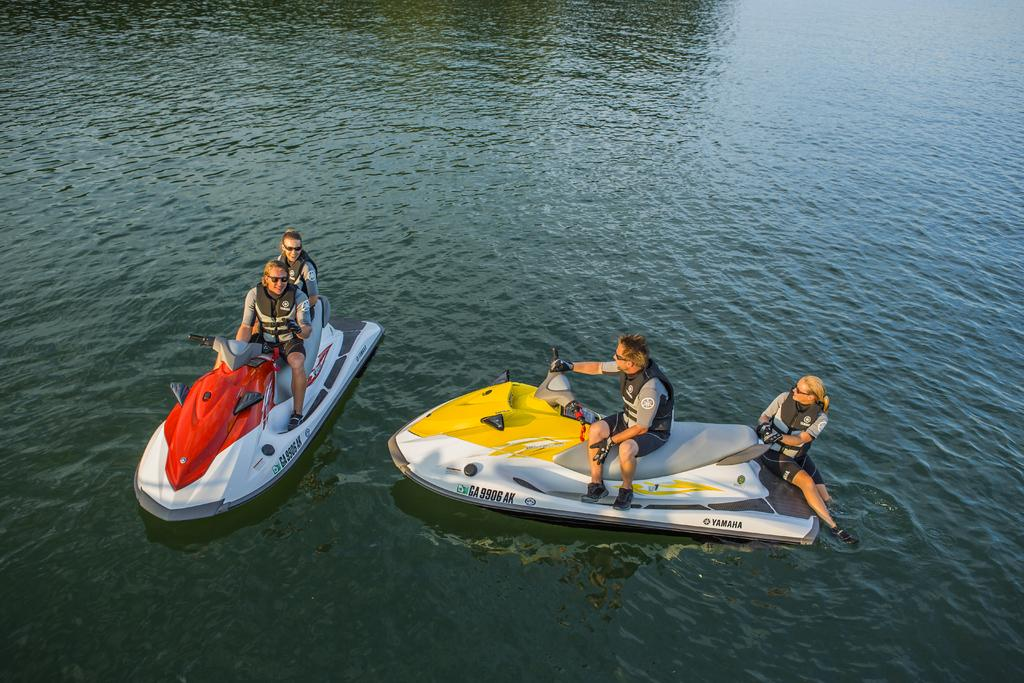How many boats are in the image? There are two boats in the image. Where are the boats located? The boats are on the water. Can you describe the people on the left boat? On the left boat, there are two persons sitting, and they are wearing jackets and goggles. How many people are on the right boat? On the right side of the image, there are two persons sitting on a boat. How many times do the persons on the left boat sort their belongings in the image? There is no indication in the image that the persons on the left boat are sorting their belongings. Can you tell me how many times the persons on the right boat sneeze in the image? There is no indication in the image that the persons on the right boat are sneezing. 